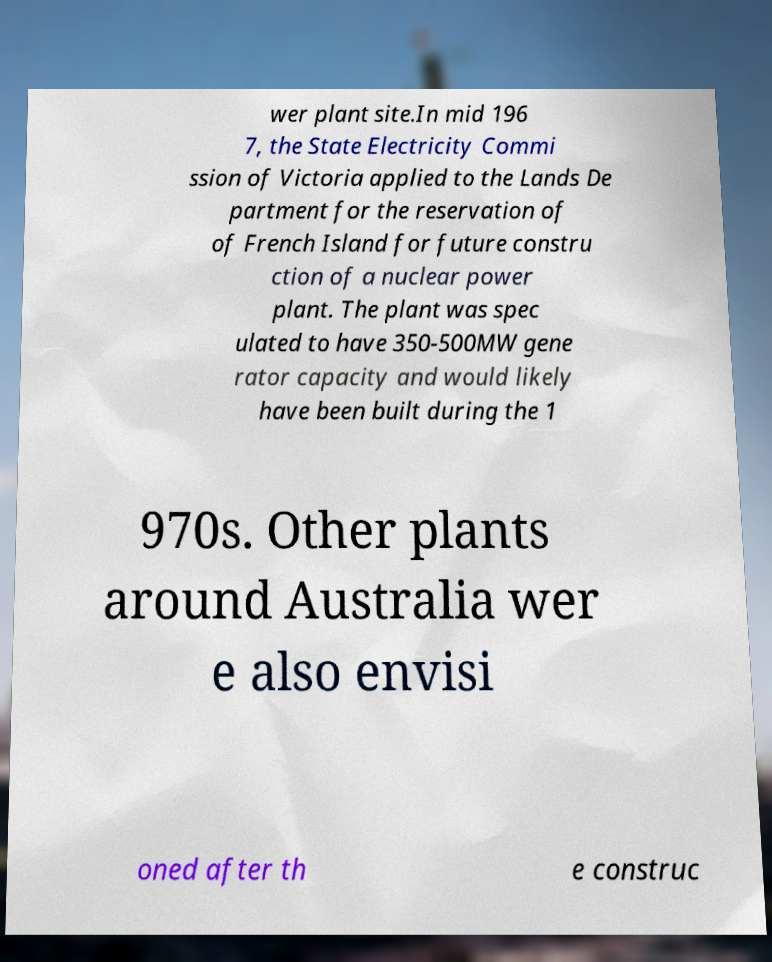There's text embedded in this image that I need extracted. Can you transcribe it verbatim? wer plant site.In mid 196 7, the State Electricity Commi ssion of Victoria applied to the Lands De partment for the reservation of of French Island for future constru ction of a nuclear power plant. The plant was spec ulated to have 350-500MW gene rator capacity and would likely have been built during the 1 970s. Other plants around Australia wer e also envisi oned after th e construc 